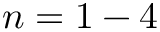Convert formula to latex. <formula><loc_0><loc_0><loc_500><loc_500>n = 1 - 4</formula> 